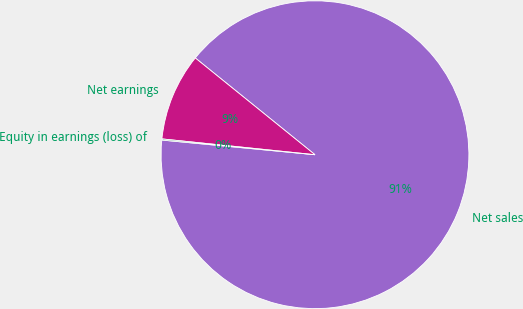Convert chart to OTSL. <chart><loc_0><loc_0><loc_500><loc_500><pie_chart><fcel>Net sales<fcel>Net earnings<fcel>Equity in earnings (loss) of<nl><fcel>90.7%<fcel>9.18%<fcel>0.12%<nl></chart> 